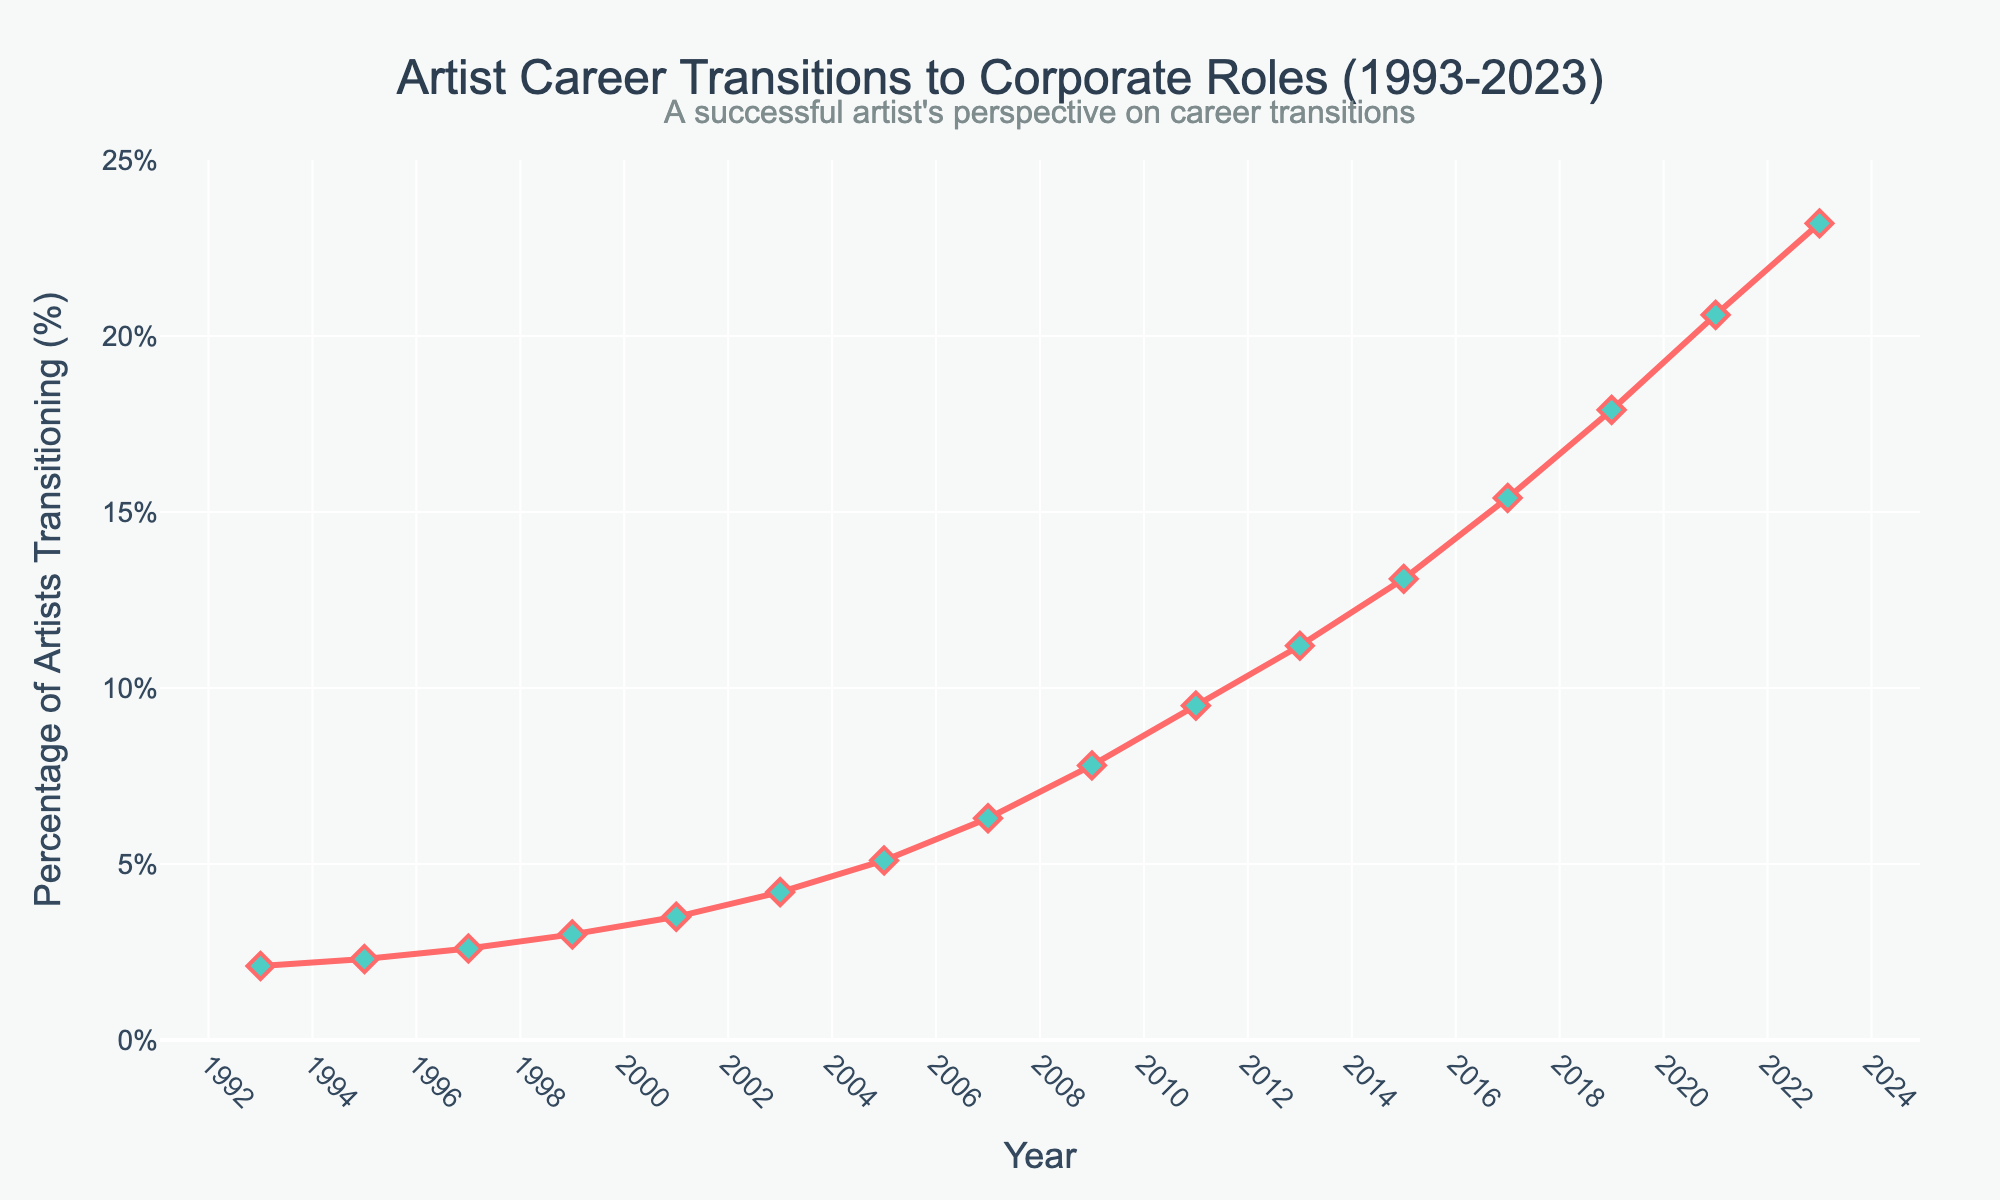What's the percentage of artists transitioning to corporate roles in 2003? Refer to the figure and find the year 2003 on the x-axis. Then, look up to the corresponding y-value to get the percentage.
Answer: 4.2% By how much did the percentage increase from 1993 to 2023? Find the percentage values for the years 1993 and 2023 from the figure: 2.1% in 1993 and 23.2% in 2023. Subtract the 1993 value from the 2023 value: 23.2% - 2.1% = 21.1%.
Answer: 21.1% Which year saw the highest rate of increase in the percentage of artists transitioning to corporate roles? To determine this, observe the steepest slope on the line chart. The segment between 2011 and 2013 shows the steepest increase, indicating the highest rate of change.
Answer: 2011-2013 Compare the percentage increase between 2001 and 2005 to that between 2005 and 2007. Which period saw a larger increase? First, find the percentages for 2001, 2005, and 2007: 3.5% (2001), 5.1% (2005), and 6.3% (2007). Calculate the increase for each period: 2001-2005: 5.1% - 3.5% = 1.6%, and 2005-2007: 6.3% - 5.1% = 1.2%. Compare the two increases: 1.6% (2001-2005) is larger than 1.2% (2005-2007).
Answer: 2001-2005 What is the average percentage of artists transitioning to corporate roles from 2015 to 2023? Find the percentages for the years 2015, 2017, 2019, 2021, and 2023: 13.1%, 15.4%, 17.9%, 20.6%, and 23.2%. Calculate the average: (13.1% + 15.4% + 17.9% + 20.6% + 23.2%) / 5 = 18.04%.
Answer: 18.04% How does the percentage in 1999 compare to that in 2009? Refer to the figure to find the percentages for 1999 and 2009. The percentage for 1999 is 3.0%, and for 2009, it is 7.8%. Compare the two: 7.8% (2009) is greater than 3.0% (1999).
Answer: 2009 is greater Is there any period when the percentage of artists transitioning stayed the same or decreased? Examine the slopes of the line; if there's any flat or downward slope, it indicates stagnation or decline. The line consistently moves upward, signifying no periods of decrease or stagnation in the percentage from 1993 to 2023.
Answer: No What's the total percentage increase from 1999 to 2017? Find the percentages for 1999 (3.0%) and 2017 (15.4%). Compute the total increase: 15.4% - 3.0% = 12.4%.
Answer: 12.4% Which year marks the first time the percentage exceeds 10%? Identify the first year on the x-axis where the y-value exceeds 10%. According to the figure, this occurs in 2013.
Answer: 2013 